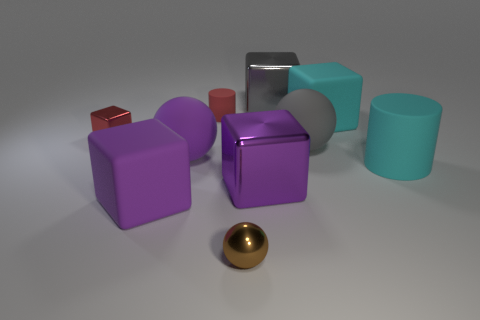There is a big sphere that is on the right side of the red cylinder; is it the same color as the large metal object that is behind the gray matte ball?
Keep it short and to the point. Yes. What number of large purple rubber cubes are there?
Ensure brevity in your answer.  1. What number of other tiny objects are the same color as the small rubber thing?
Provide a succinct answer. 1. There is a matte thing on the left side of the purple sphere; does it have the same shape as the large purple object to the right of the brown shiny sphere?
Offer a very short reply. Yes. What is the color of the big matte block that is to the left of the shiny cube in front of the big cyan rubber thing right of the big cyan cube?
Your answer should be compact. Purple. The large matte cube that is in front of the big purple shiny cube is what color?
Make the answer very short. Purple. There is a cube that is the same size as the metal ball; what is its color?
Ensure brevity in your answer.  Red. Do the gray shiny object and the red rubber object have the same size?
Provide a succinct answer. No. How many large metal things are to the right of the small red matte thing?
Your answer should be compact. 2. How many objects are metallic objects that are in front of the gray metal thing or purple matte spheres?
Offer a terse response. 4. 